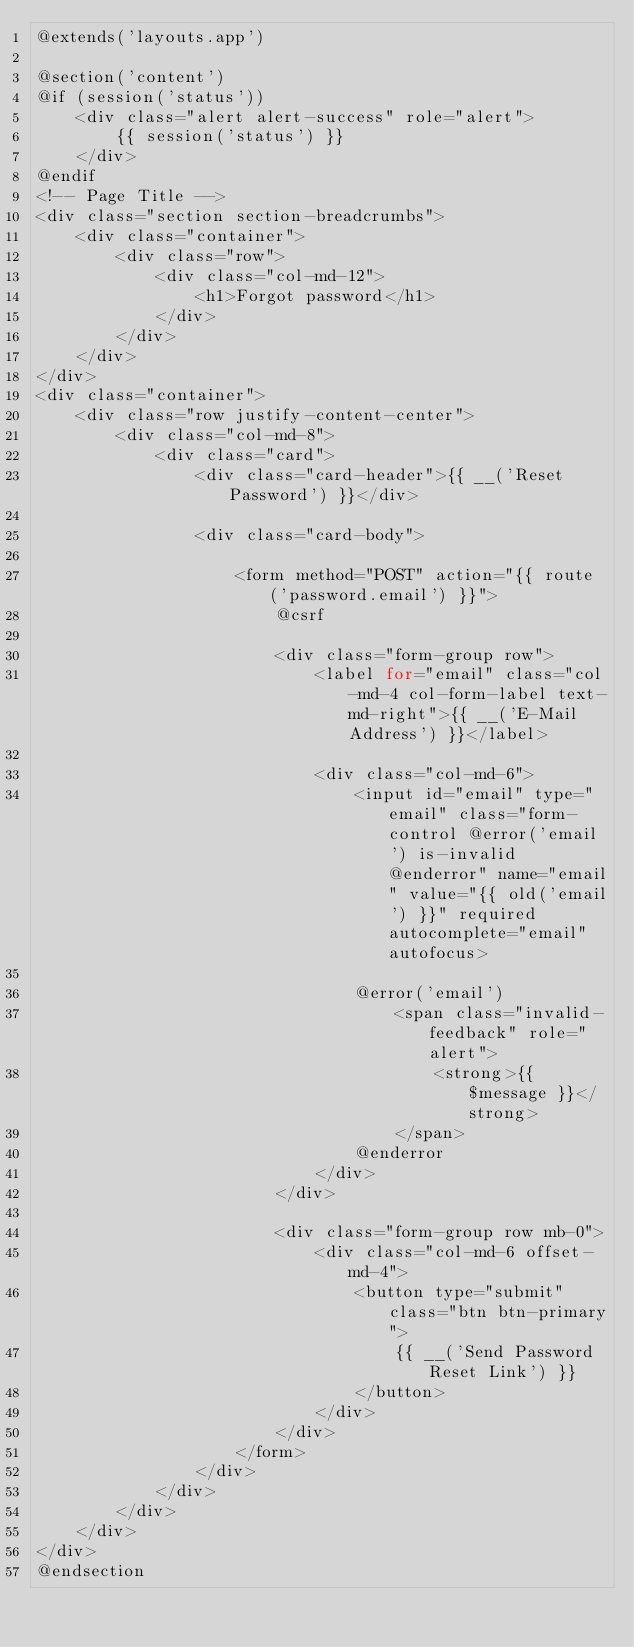<code> <loc_0><loc_0><loc_500><loc_500><_PHP_>@extends('layouts.app')

@section('content')
@if (session('status'))
    <div class="alert alert-success" role="alert">
        {{ session('status') }}
    </div>
@endif
<!-- Page Title -->
<div class="section section-breadcrumbs">
    <div class="container">
        <div class="row">
            <div class="col-md-12">
                <h1>Forgot password</h1>
            </div>
        </div>
    </div>
</div>
<div class="container">
    <div class="row justify-content-center">
        <div class="col-md-8">
            <div class="card">
                <div class="card-header">{{ __('Reset Password') }}</div>

                <div class="card-body">

                    <form method="POST" action="{{ route('password.email') }}">
                        @csrf

                        <div class="form-group row">
                            <label for="email" class="col-md-4 col-form-label text-md-right">{{ __('E-Mail Address') }}</label>

                            <div class="col-md-6">
                                <input id="email" type="email" class="form-control @error('email') is-invalid @enderror" name="email" value="{{ old('email') }}" required autocomplete="email" autofocus>

                                @error('email')
                                    <span class="invalid-feedback" role="alert">
                                        <strong>{{ $message }}</strong>
                                    </span>
                                @enderror
                            </div>
                        </div>

                        <div class="form-group row mb-0">
                            <div class="col-md-6 offset-md-4">
                                <button type="submit" class="btn btn-primary">
                                    {{ __('Send Password Reset Link') }}
                                </button>
                            </div>
                        </div>
                    </form>
                </div>
            </div>
        </div>
    </div>
</div>
@endsection
</code> 